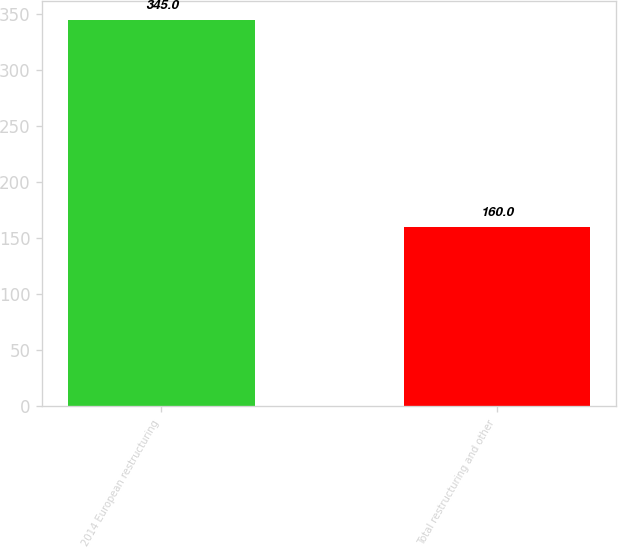<chart> <loc_0><loc_0><loc_500><loc_500><bar_chart><fcel>2014 European restructuring<fcel>Total restructuring and other<nl><fcel>345<fcel>160<nl></chart> 